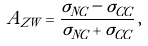<formula> <loc_0><loc_0><loc_500><loc_500>A _ { Z W } = \frac { \sigma _ { N C } - \sigma _ { C C } } { \sigma _ { N C } + \sigma _ { C C } } \, ,</formula> 